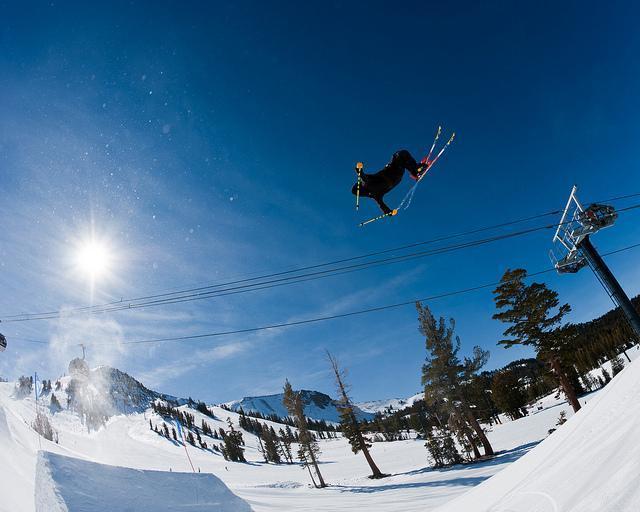How many dogs are following the horse?
Give a very brief answer. 0. 